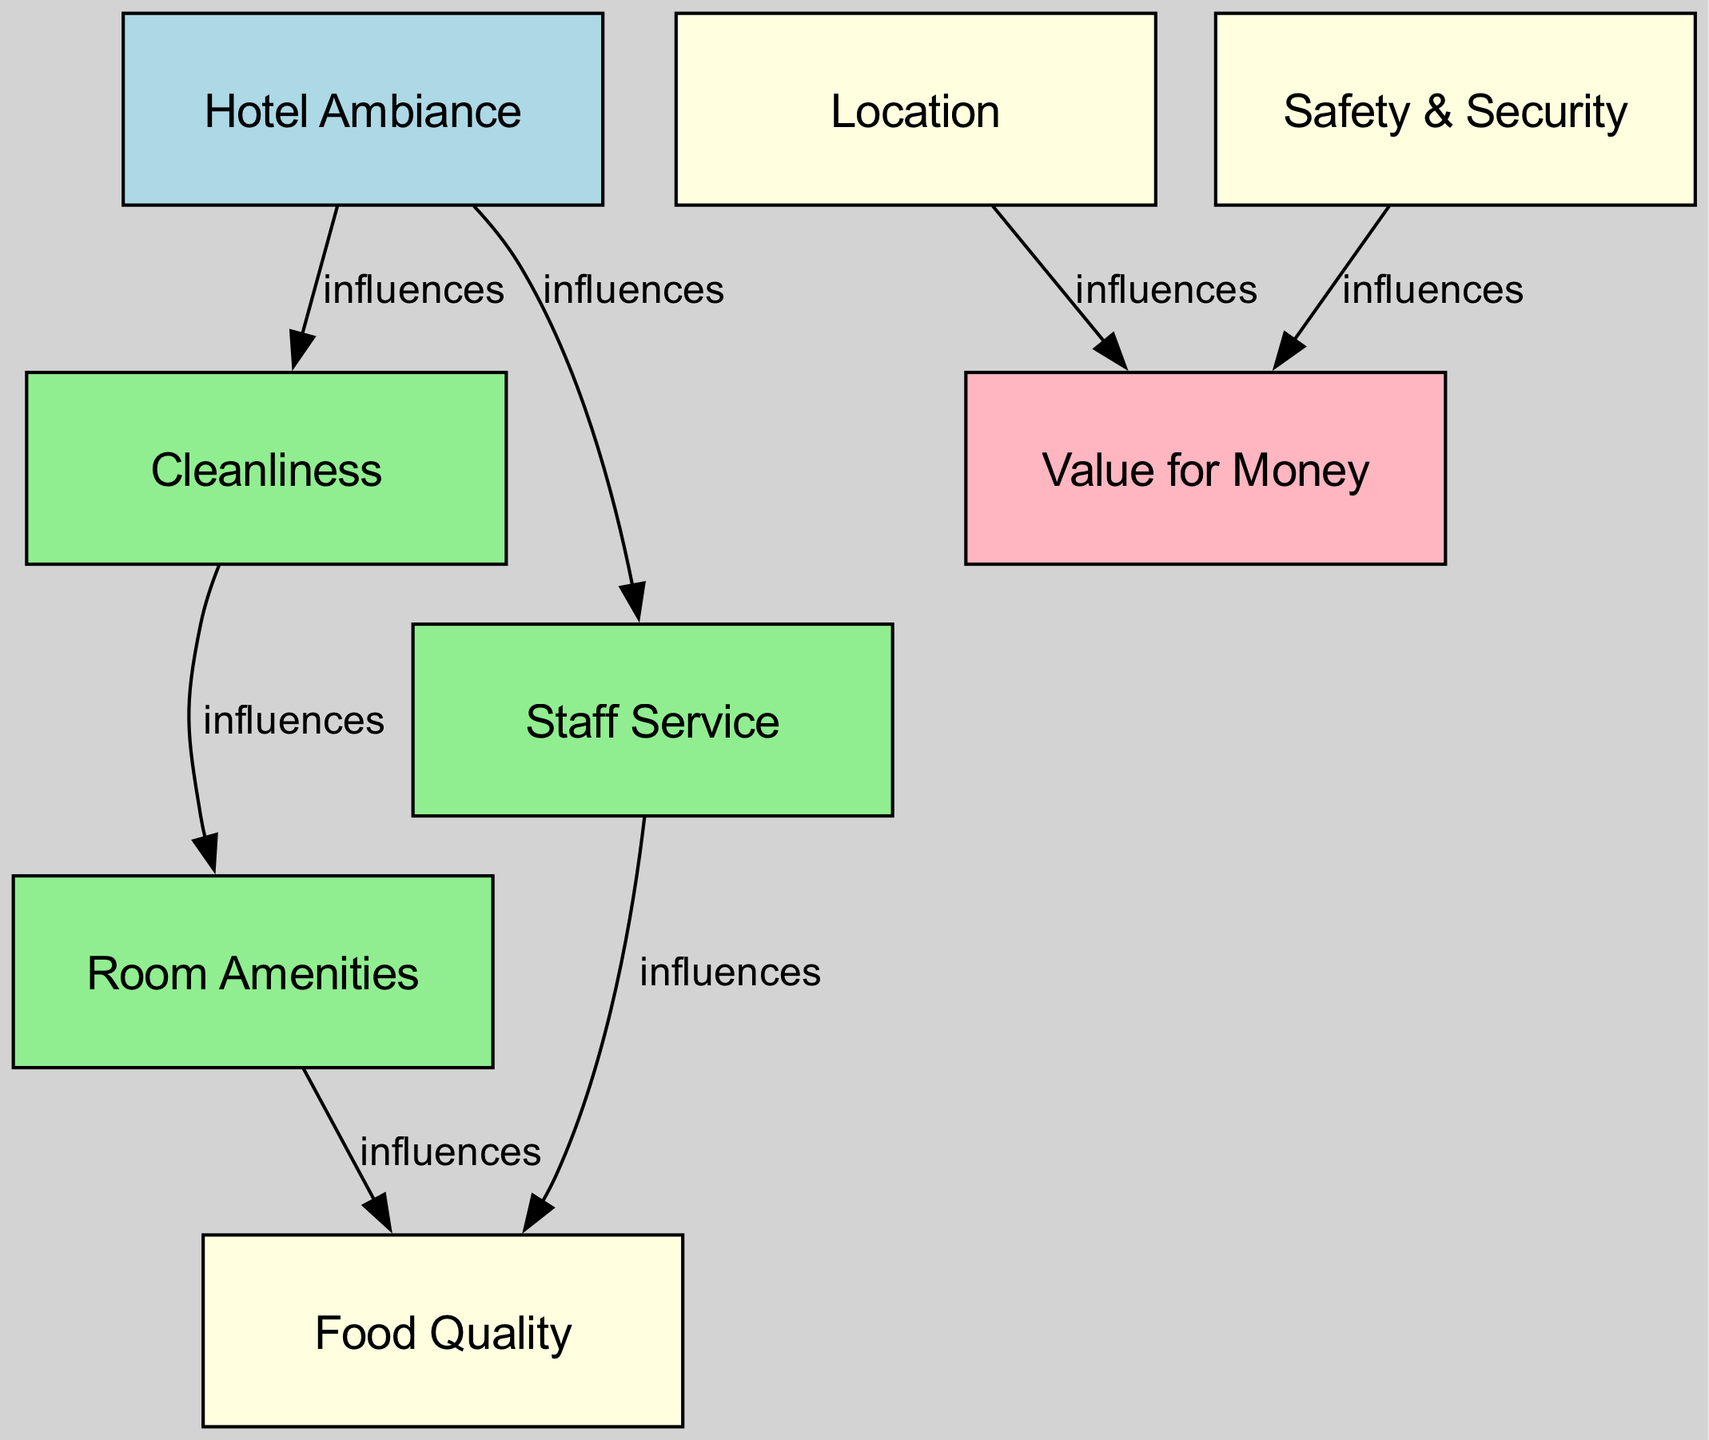What are the colors attributed to the node "Cleanliness"? The node "Cleanliness" is colored light green, which can be seen in the diagram by identifying the specific node and noting its assigned fill color.
Answer: light green How many nodes are there in the diagram? By counting each individual node listed in the dataset, there are a total of 8 nodes present in the diagram.
Answer: 8 What influences "Food Quality"? "Food Quality" is influenced by "Staff Service" and "Room Amenities", as indicated by the edges pointing from both of these nodes towards "Food Quality".
Answer: Staff Service, Room Amenities Which node directly influences "Value for Money"? In the diagram, "Location" and "Safety & Security" are the nodes that directly influence "Value for Money", as there are edges leading from both towards it.
Answer: Location, Safety & Security If "Hotel Ambiance" is rated poorly, how might it impact "Cleanliness"? "Hotel Ambiance" influences "Cleanliness" in the diagram, which means if "Hotel Ambiance" is rated poorly, there may be a negative impact on "Cleanliness" as well, demonstrating the connection indicated by the edge.
Answer: Negative impact What is the relationship between "Room Amenities" and "Cleanliness"? The diagram indicates no direct relationship between "Room Amenities" and "Cleanliness" as no edge connects these two nodes, meaning that "Room Amenities" does not influence "Cleanliness" directly in this context.
Answer: No direct relationship Which two factors influence "Value for Money" in the diagram? The edges leading toward "Value for Money" show that both "Location" and "Safety & Security" are factors that influence it, based on the directed connections present in the diagram.
Answer: Location, Safety & Security How many edges are there connecting the nodes? By counting the number of directed connections (edges) listed in the dataset, there are a total of 7 edges present in the diagram.
Answer: 7 What is the first factor considered in the hotel inspection process? The diagram shows "Hotel Ambiance" as the first factor, as it is the topmost node and has outgoing edges to other nodes, indicating it is the starting point for influences in the inspection.
Answer: Hotel Ambiance 